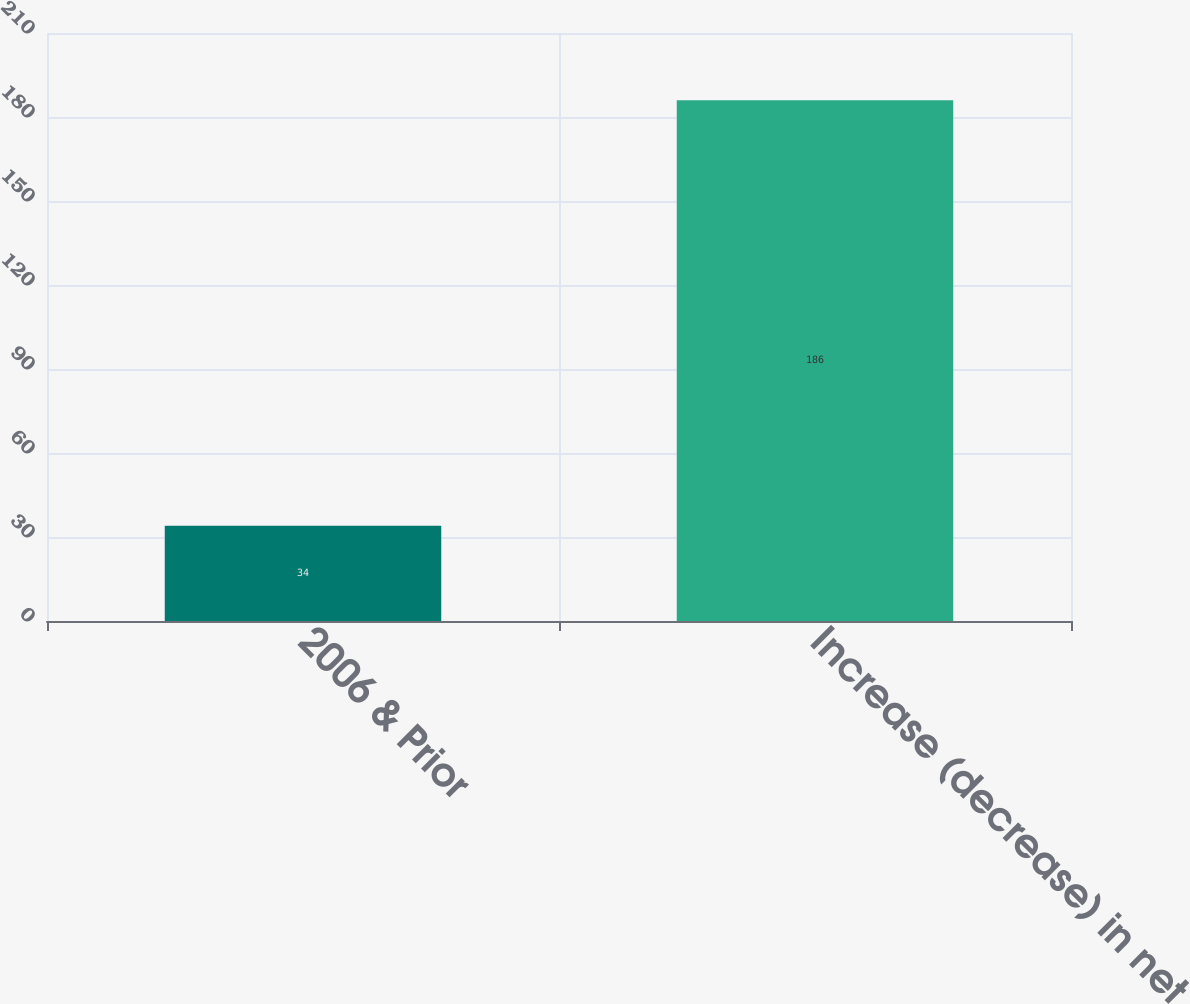Convert chart. <chart><loc_0><loc_0><loc_500><loc_500><bar_chart><fcel>2006 & Prior<fcel>Increase (decrease) in net<nl><fcel>34<fcel>186<nl></chart> 